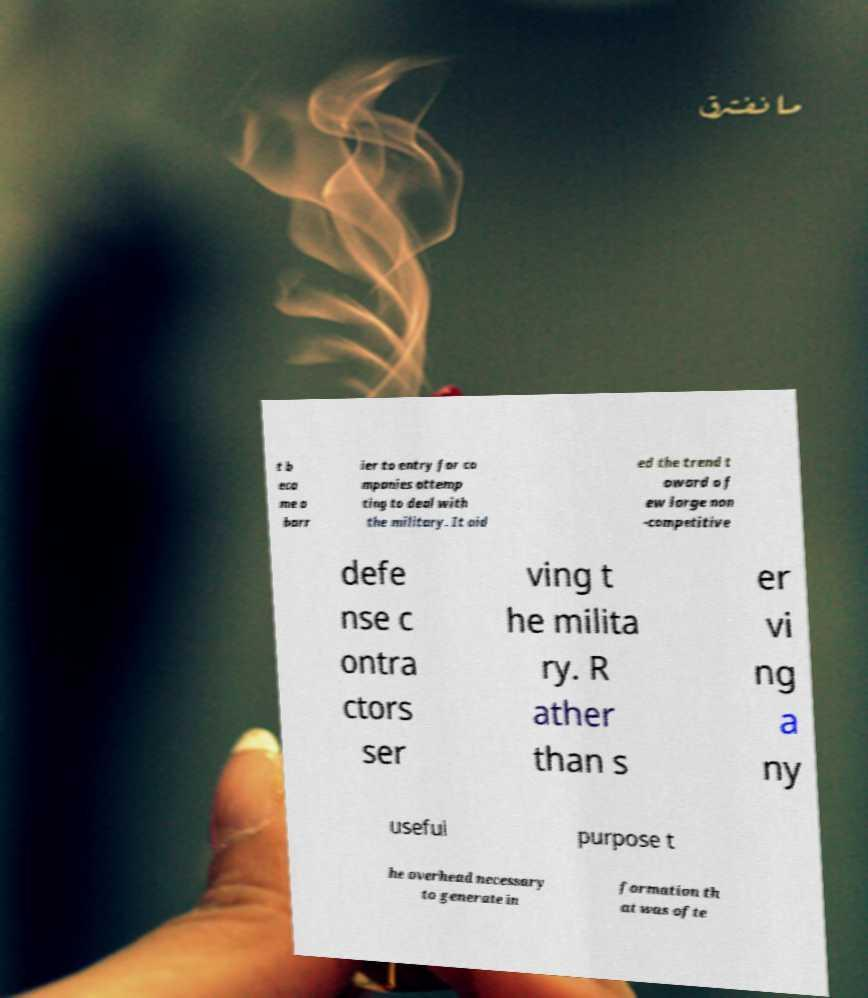What messages or text are displayed in this image? I need them in a readable, typed format. t b eca me a barr ier to entry for co mpanies attemp ting to deal with the military. It aid ed the trend t oward a f ew large non -competitive defe nse c ontra ctors ser ving t he milita ry. R ather than s er vi ng a ny useful purpose t he overhead necessary to generate in formation th at was ofte 